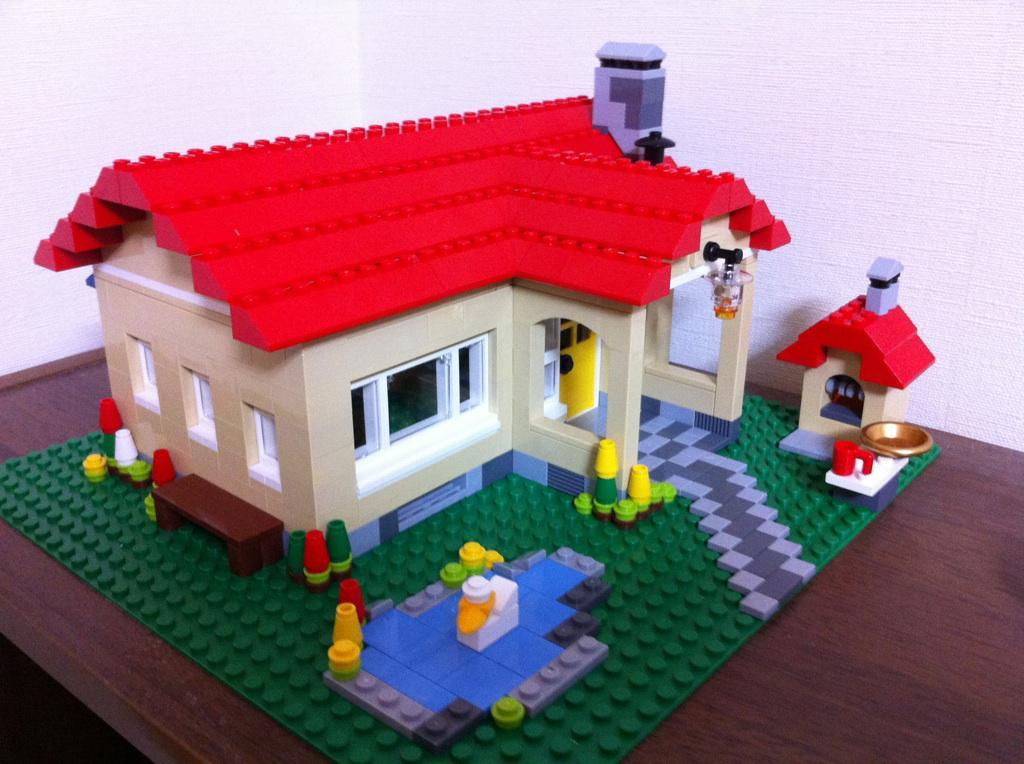What type of furniture is present in the image? There is a table in the image. What is on top of the table? There are objects on the table. What can be seen behind the table? There is a wall visible in the image. How does the butter grip the objects on the table in the image? There is no butter present in the image, so it cannot grip any objects. 